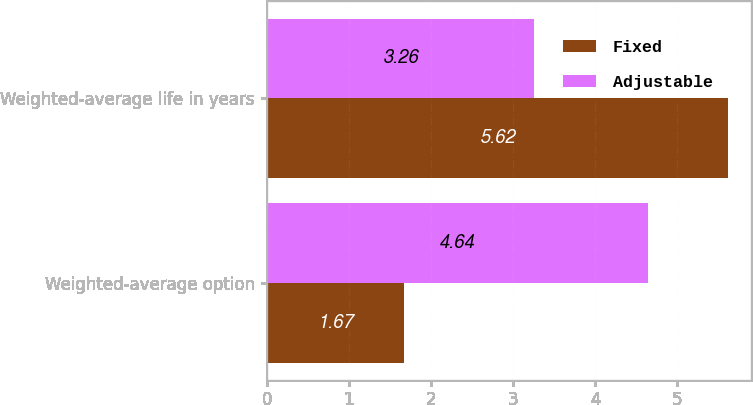<chart> <loc_0><loc_0><loc_500><loc_500><stacked_bar_chart><ecel><fcel>Weighted-average option<fcel>Weighted-average life in years<nl><fcel>Fixed<fcel>1.67<fcel>5.62<nl><fcel>Adjustable<fcel>4.64<fcel>3.26<nl></chart> 